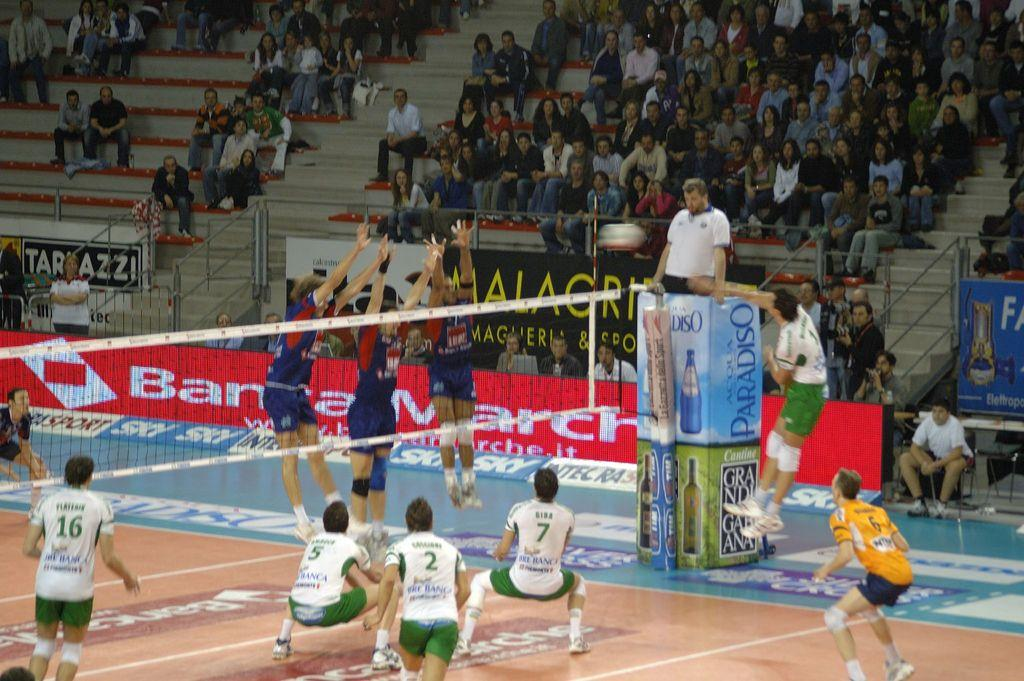<image>
Relay a brief, clear account of the picture shown. A volleyball game played indoors sponsored by Paradiso. 